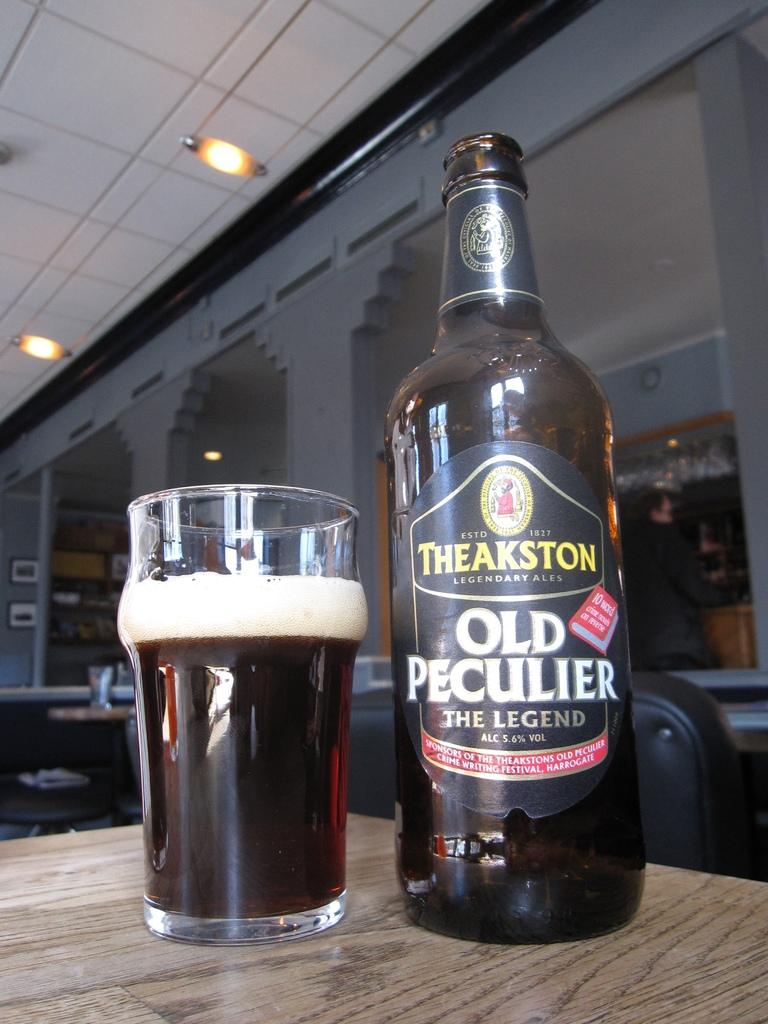Provide a one-sentence caption for the provided image. Old Peculiar is the flavor of the beer being poured. 